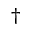Convert formula to latex. <formula><loc_0><loc_0><loc_500><loc_500>\dagger</formula> 